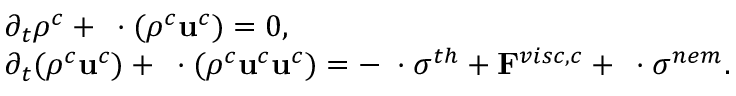<formula> <loc_0><loc_0><loc_500><loc_500>\begin{array} { r l } & { \partial _ { t } \rho ^ { c } + \nabla \cdot ( \rho ^ { c } u ^ { c } ) = 0 , } \\ & { \partial _ { t } ( \rho ^ { c } u ^ { c } ) + \nabla \cdot ( \rho ^ { c } u ^ { c } u ^ { c } ) = - \nabla \cdot \sigma ^ { t h } + F ^ { v i s c , c } + \nabla \cdot \sigma ^ { n e m } . } \end{array}</formula> 